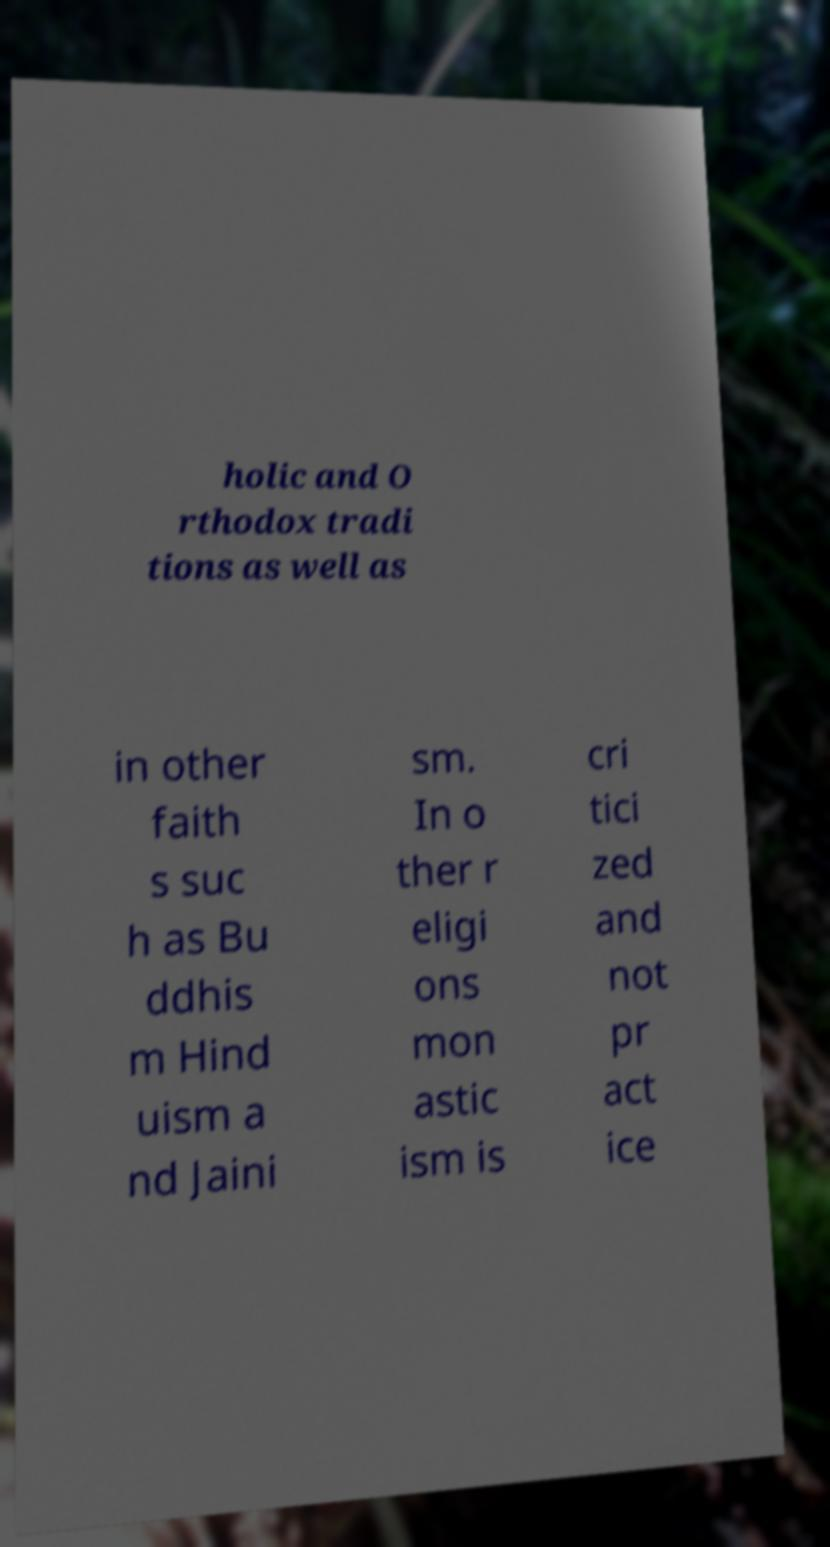Can you read and provide the text displayed in the image?This photo seems to have some interesting text. Can you extract and type it out for me? holic and O rthodox tradi tions as well as in other faith s suc h as Bu ddhis m Hind uism a nd Jaini sm. In o ther r eligi ons mon astic ism is cri tici zed and not pr act ice 